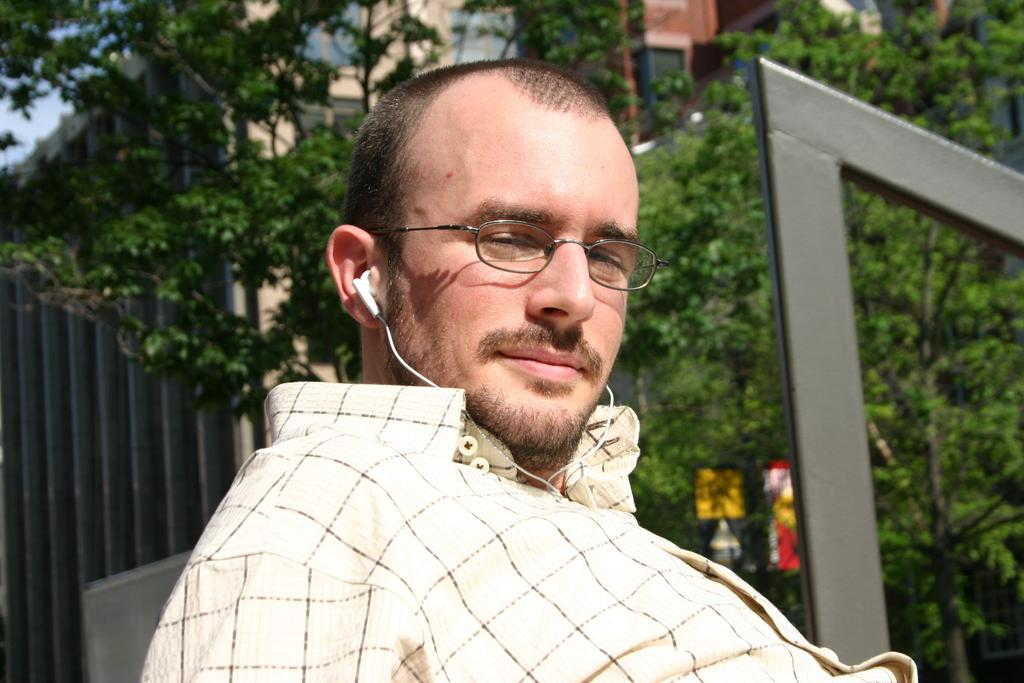Who is the main subject in the image? There is a man in the center of the image. What can be seen in the background of the image? There are buildings and trees in the background of the image. What type of drug is the man holding in the image? There is no drug present in the image; the man is not holding anything. 